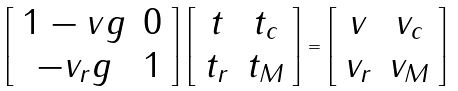<formula> <loc_0><loc_0><loc_500><loc_500>\left [ \begin{array} { c c } 1 - v g & 0 \\ - v _ { r } g & 1 \end{array} \right ] \left [ \begin{array} { c c } t & t _ { c } \\ t _ { r } & t _ { M } \end{array} \right ] = \left [ \begin{array} { c c } v & v _ { c } \\ v _ { r } & v _ { M } \end{array} \right ]</formula> 